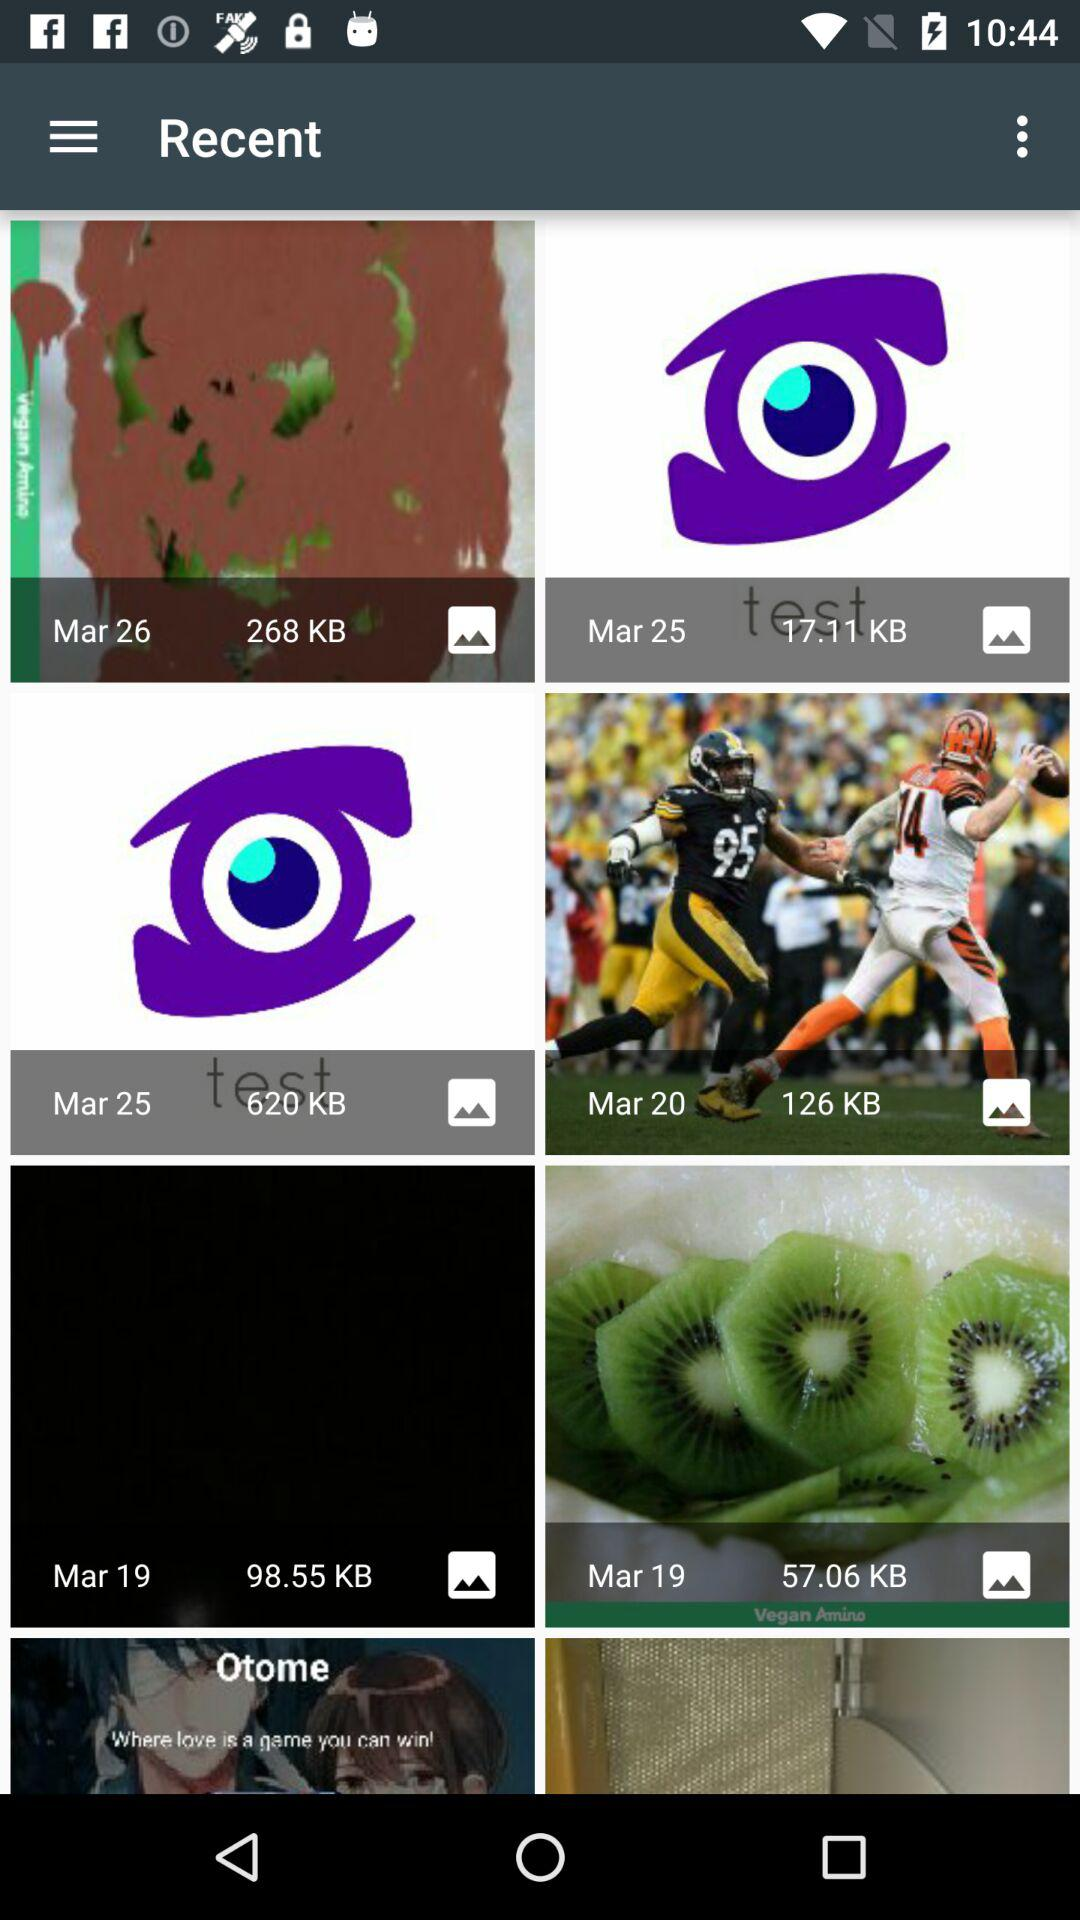What is the size of the image on March 26th? The size of the image is 268 KB. 